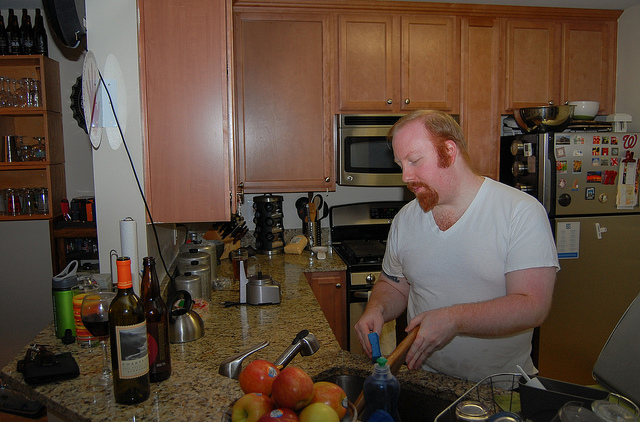Can you describe the person in the image? Certainly! The person in the image is a male with a beard, wearing a white T-shirt. He is standing at the kitchen counter, actively engaging in some kind of food preparation, which suggests that he could be in the midst of cooking or organizing the kitchen space. What does his activity tell us about the kitchen environment? His activity indicates a functional kitchen environment that is currently in use. The presence of various cooking utensils, a busy countertop, and an array of ingredients point to an individual who appears to be comfortable in this space, perhaps preparing for a meal or organizing the kitchen after use. 